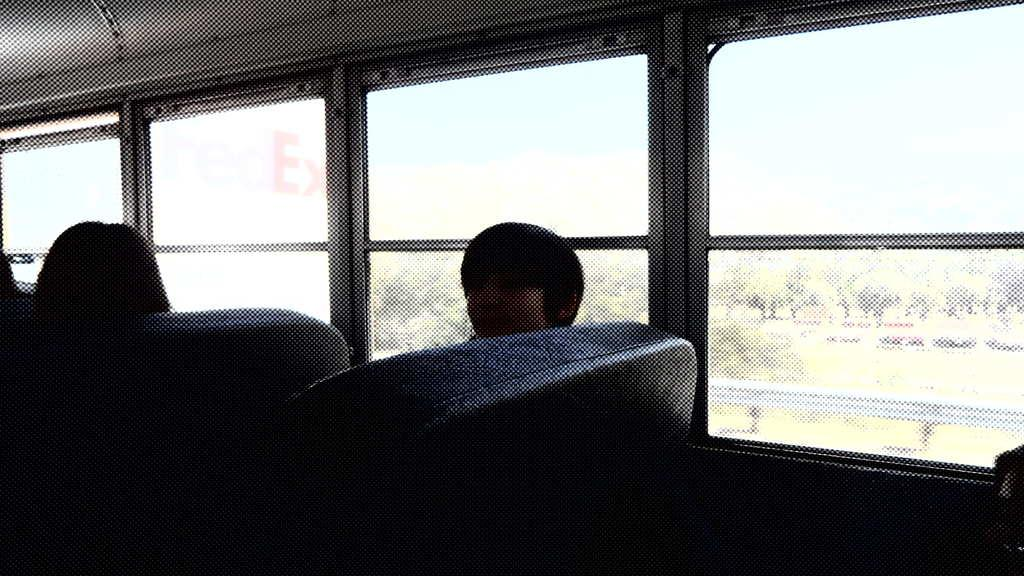What are the people in the image doing? The people are sitting in a vehicle. Where are the people sitting in the vehicle? The people are sitting on seats. What is a feature of the vehicle that allows visibility? There is a glass window in the vehicle. What can be seen through the glass window? Trees are visible through the glass window. What does the queen do in the image? There is no queen present in the image. How does the act of sitting in the vehicle affect the people's ability to be quiet? The image does not provide information about the people's ability to be quiet, nor does it mention any acts related to sitting in the vehicle. 